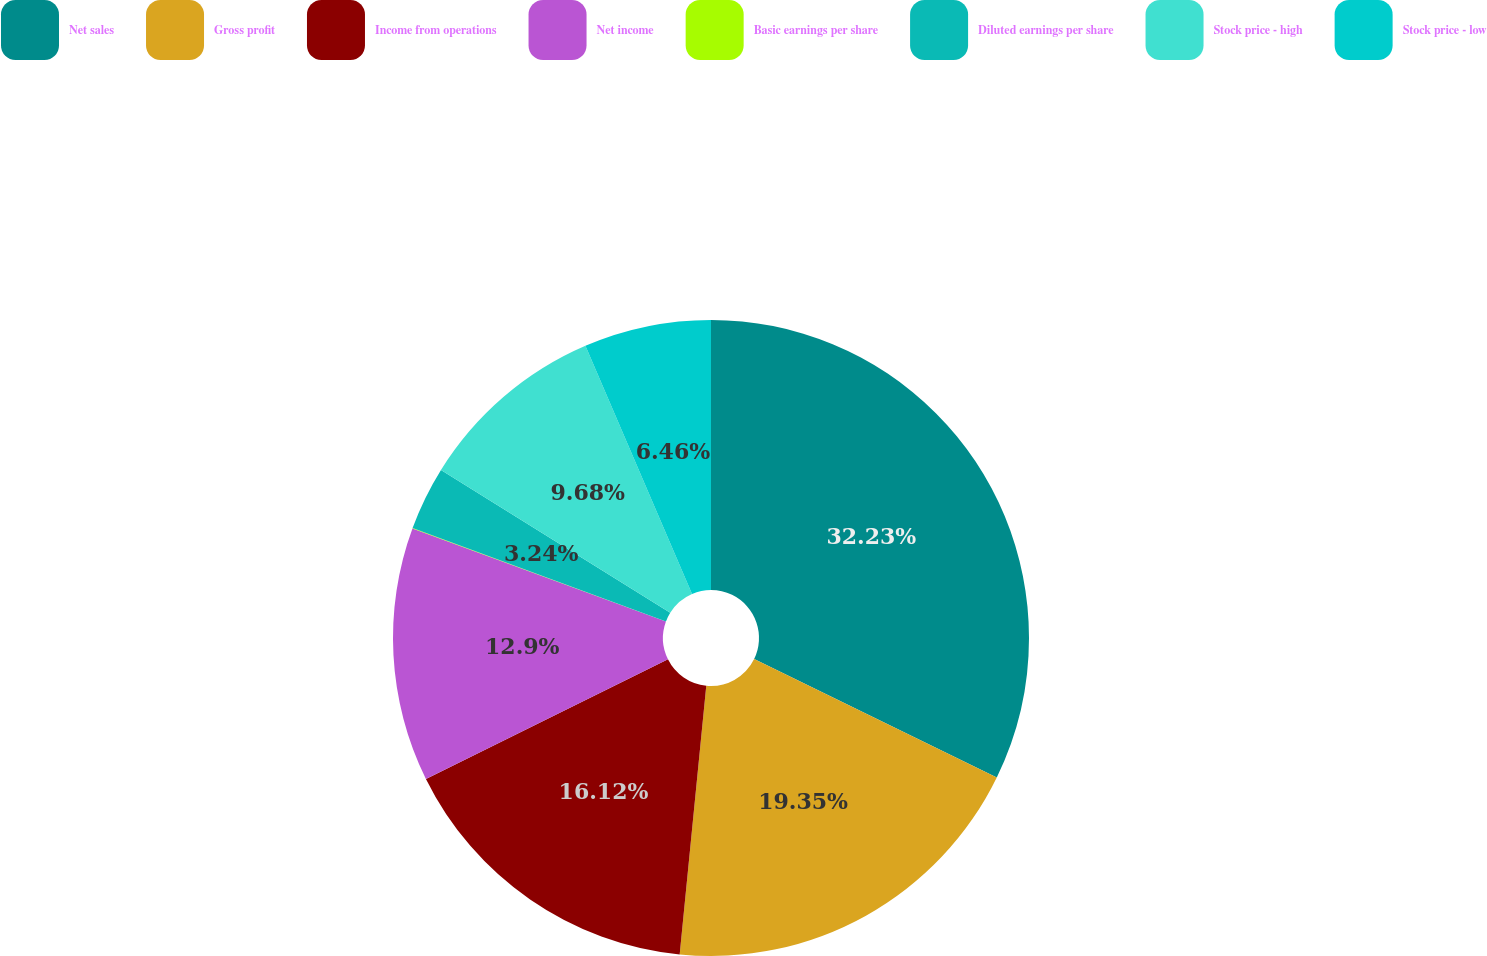<chart> <loc_0><loc_0><loc_500><loc_500><pie_chart><fcel>Net sales<fcel>Gross profit<fcel>Income from operations<fcel>Net income<fcel>Basic earnings per share<fcel>Diluted earnings per share<fcel>Stock price - high<fcel>Stock price - low<nl><fcel>32.22%<fcel>19.34%<fcel>16.12%<fcel>12.9%<fcel>0.02%<fcel>3.24%<fcel>9.68%<fcel>6.46%<nl></chart> 